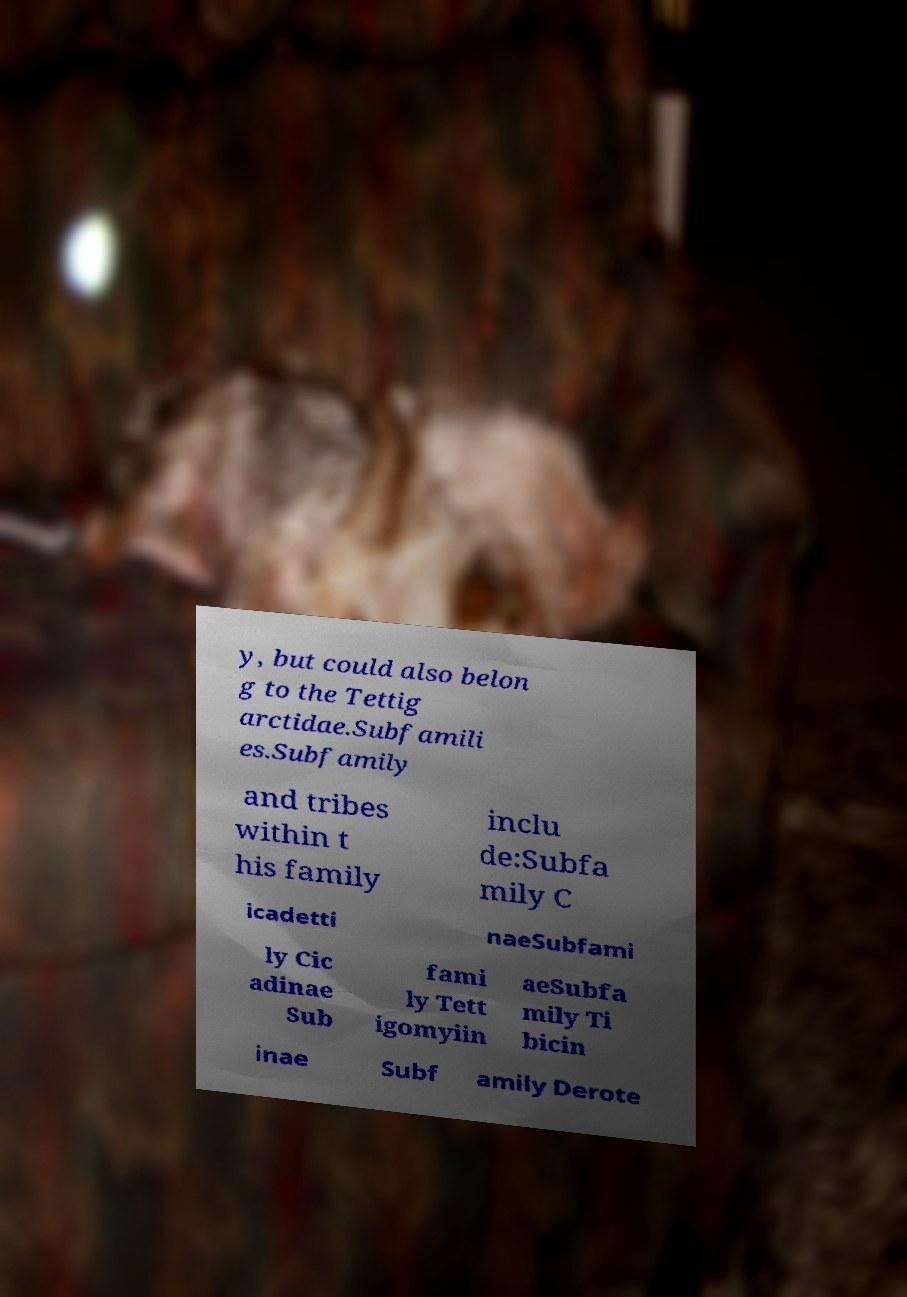There's text embedded in this image that I need extracted. Can you transcribe it verbatim? y, but could also belon g to the Tettig arctidae.Subfamili es.Subfamily and tribes within t his family inclu de:Subfa mily C icadetti naeSubfami ly Cic adinae Sub fami ly Tett igomyiin aeSubfa mily Ti bicin inae Subf amily Derote 